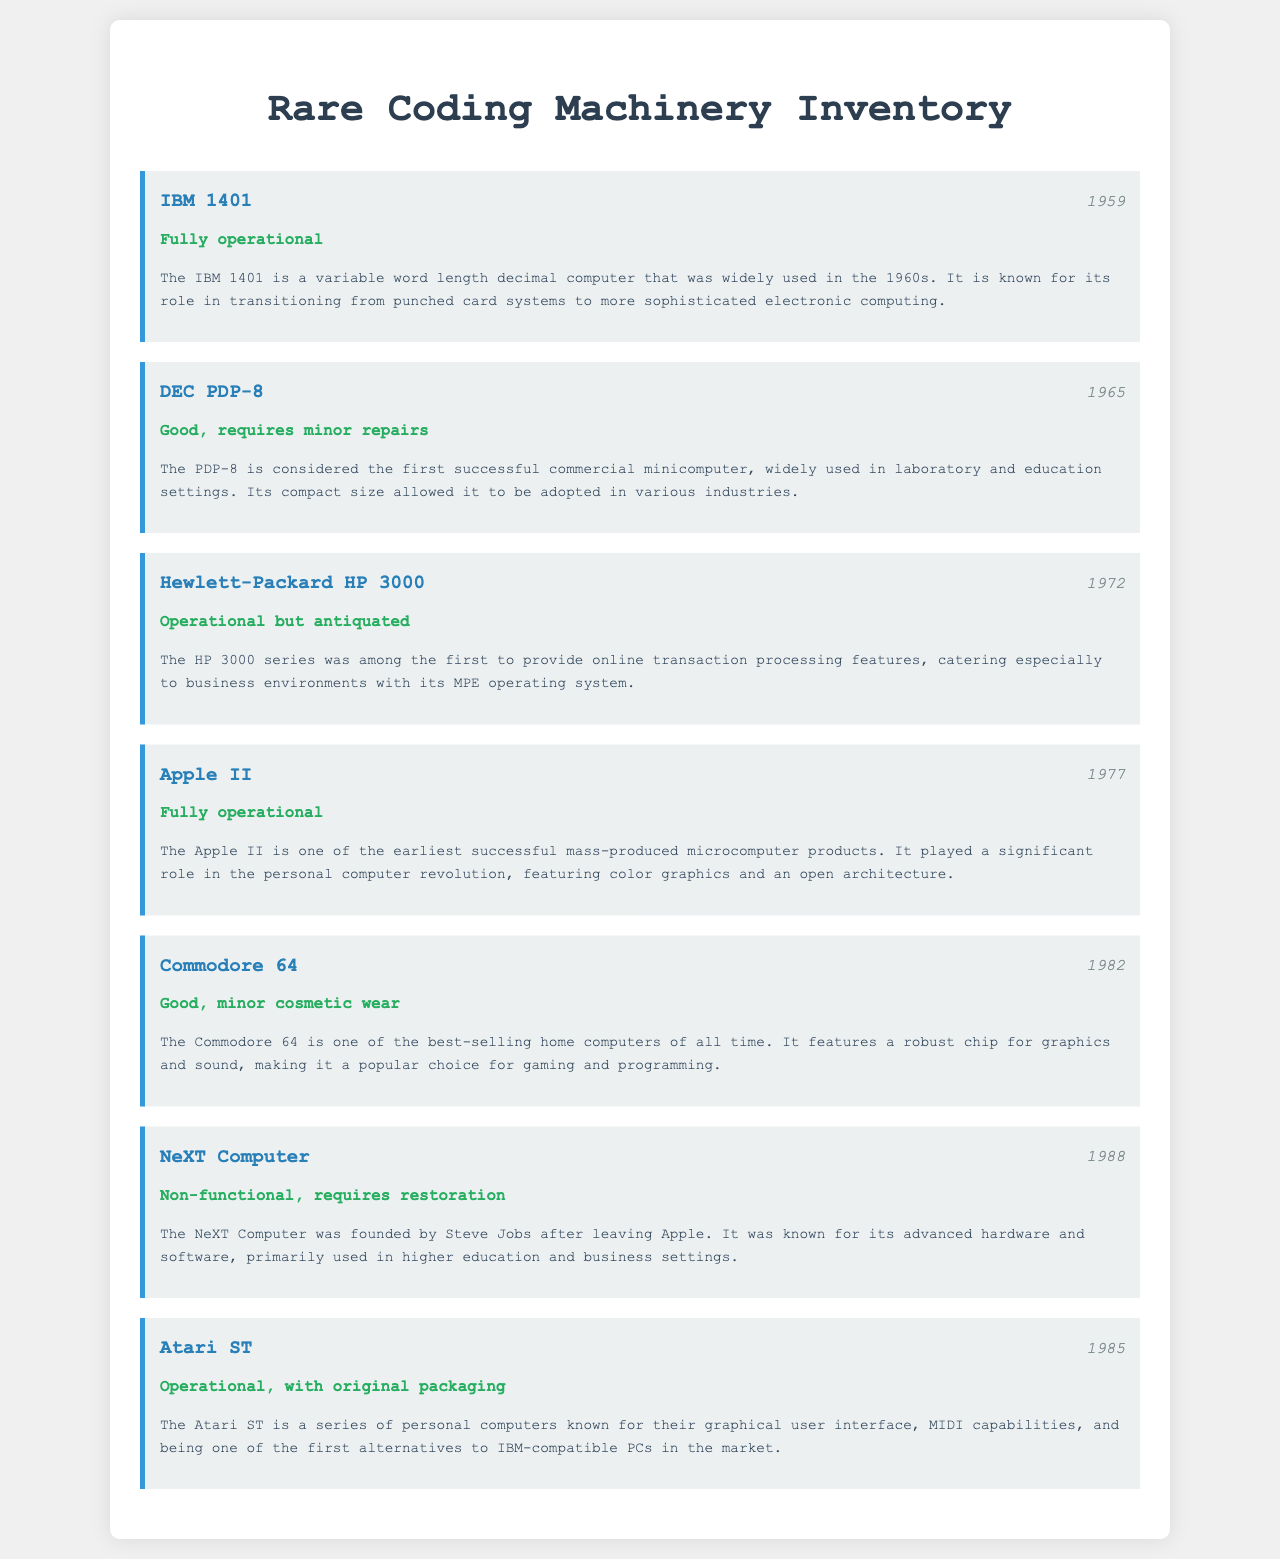What is the make of the first item? The first item listed is the IBM 1401, which is mentioned at the top of the inventory.
Answer: IBM 1401 What year was the DEC PDP-8 manufactured? The year of manufacture for the DEC PDP-8 can be found beside its name in the inventory list.
Answer: 1965 What is the current condition of the Hewlett-Packard HP 3000? The condition of the Hewlett-Packard HP 3000 is stated directly below its year of manufacture in the inventory list.
Answer: Operational but antiquated Which item is described as non-functional? The inventory describes the NeXT Computer as non-functional in its current state.
Answer: NeXT Computer How many items are listed in the inventory? The total number of items can be counted directly from the inventory section of the document.
Answer: Seven What feature made the Apple II significant? The description of the Apple II highlights its role in the personal computer revolution, featuring color graphics and an open architecture.
Answer: Color graphics and open architecture Which machine requires minor repairs? The condition of the DEC PDP-8 indicates that it requires minor repairs.
Answer: DEC PDP-8 What year was the Commodore 64 created? The year of manufacture for the Commodore 64 is provided beside its name in the inventory list.
Answer: 1982 What does the Atari ST stand out for? The description of the Atari ST notes its graphical user interface and MIDI capabilities as important features.
Answer: Graphical user interface and MIDI capabilities 